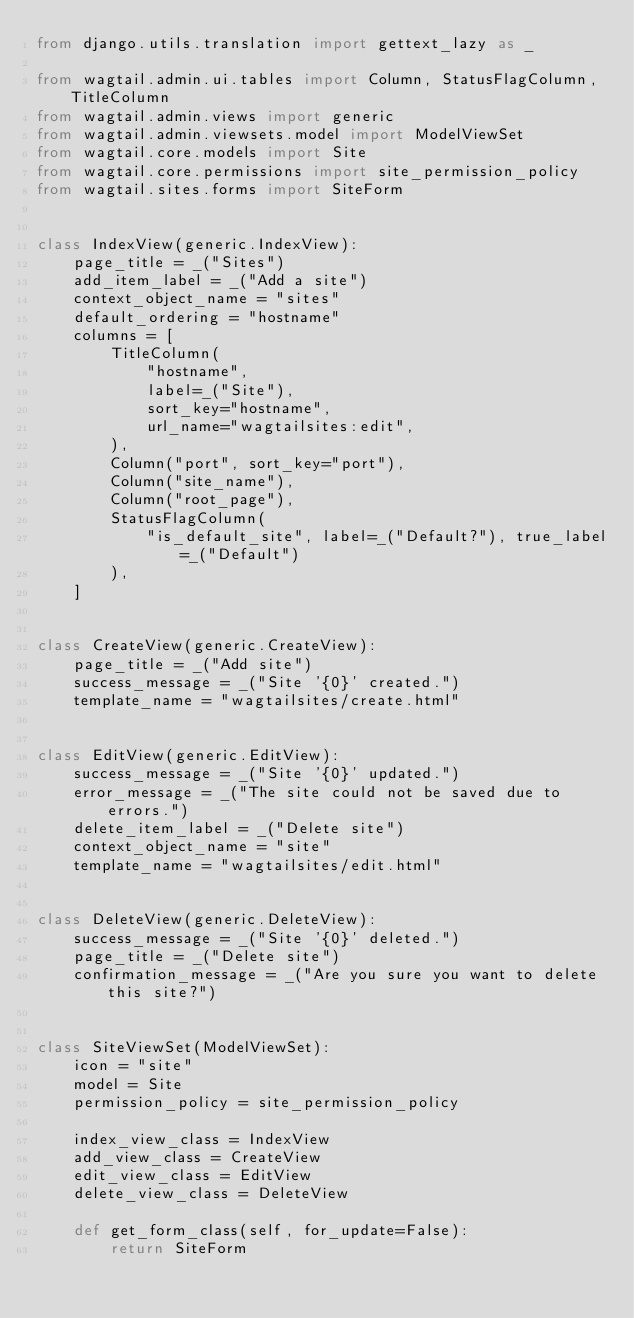<code> <loc_0><loc_0><loc_500><loc_500><_Python_>from django.utils.translation import gettext_lazy as _

from wagtail.admin.ui.tables import Column, StatusFlagColumn, TitleColumn
from wagtail.admin.views import generic
from wagtail.admin.viewsets.model import ModelViewSet
from wagtail.core.models import Site
from wagtail.core.permissions import site_permission_policy
from wagtail.sites.forms import SiteForm


class IndexView(generic.IndexView):
    page_title = _("Sites")
    add_item_label = _("Add a site")
    context_object_name = "sites"
    default_ordering = "hostname"
    columns = [
        TitleColumn(
            "hostname",
            label=_("Site"),
            sort_key="hostname",
            url_name="wagtailsites:edit",
        ),
        Column("port", sort_key="port"),
        Column("site_name"),
        Column("root_page"),
        StatusFlagColumn(
            "is_default_site", label=_("Default?"), true_label=_("Default")
        ),
    ]


class CreateView(generic.CreateView):
    page_title = _("Add site")
    success_message = _("Site '{0}' created.")
    template_name = "wagtailsites/create.html"


class EditView(generic.EditView):
    success_message = _("Site '{0}' updated.")
    error_message = _("The site could not be saved due to errors.")
    delete_item_label = _("Delete site")
    context_object_name = "site"
    template_name = "wagtailsites/edit.html"


class DeleteView(generic.DeleteView):
    success_message = _("Site '{0}' deleted.")
    page_title = _("Delete site")
    confirmation_message = _("Are you sure you want to delete this site?")


class SiteViewSet(ModelViewSet):
    icon = "site"
    model = Site
    permission_policy = site_permission_policy

    index_view_class = IndexView
    add_view_class = CreateView
    edit_view_class = EditView
    delete_view_class = DeleteView

    def get_form_class(self, for_update=False):
        return SiteForm
</code> 